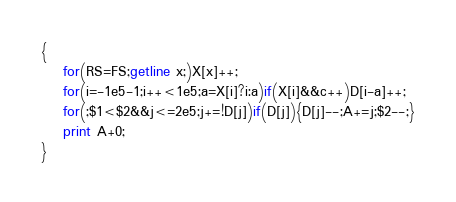<code> <loc_0><loc_0><loc_500><loc_500><_Awk_>{
    for(RS=FS;getline x;)X[x]++;
    for(i=-1e5-1;i++<1e5;a=X[i]?i:a)if(X[i]&&c++)D[i-a]++;
    for(;$1<$2&&j<=2e5;j+=!D[j])if(D[j]){D[j]--;A+=j;$2--;}
    print A+0;
}</code> 